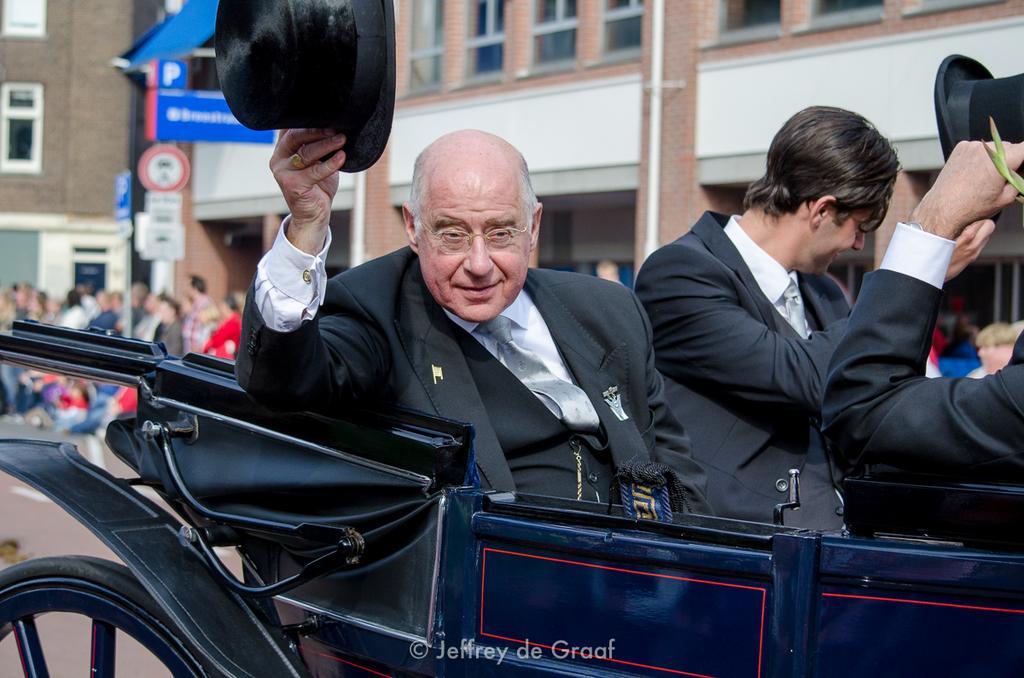Can you describe this image briefly? In this picture there are two men sitting in a Chariot, wearing hats. In the background, there are some people standing and we can observe some buildings here. 